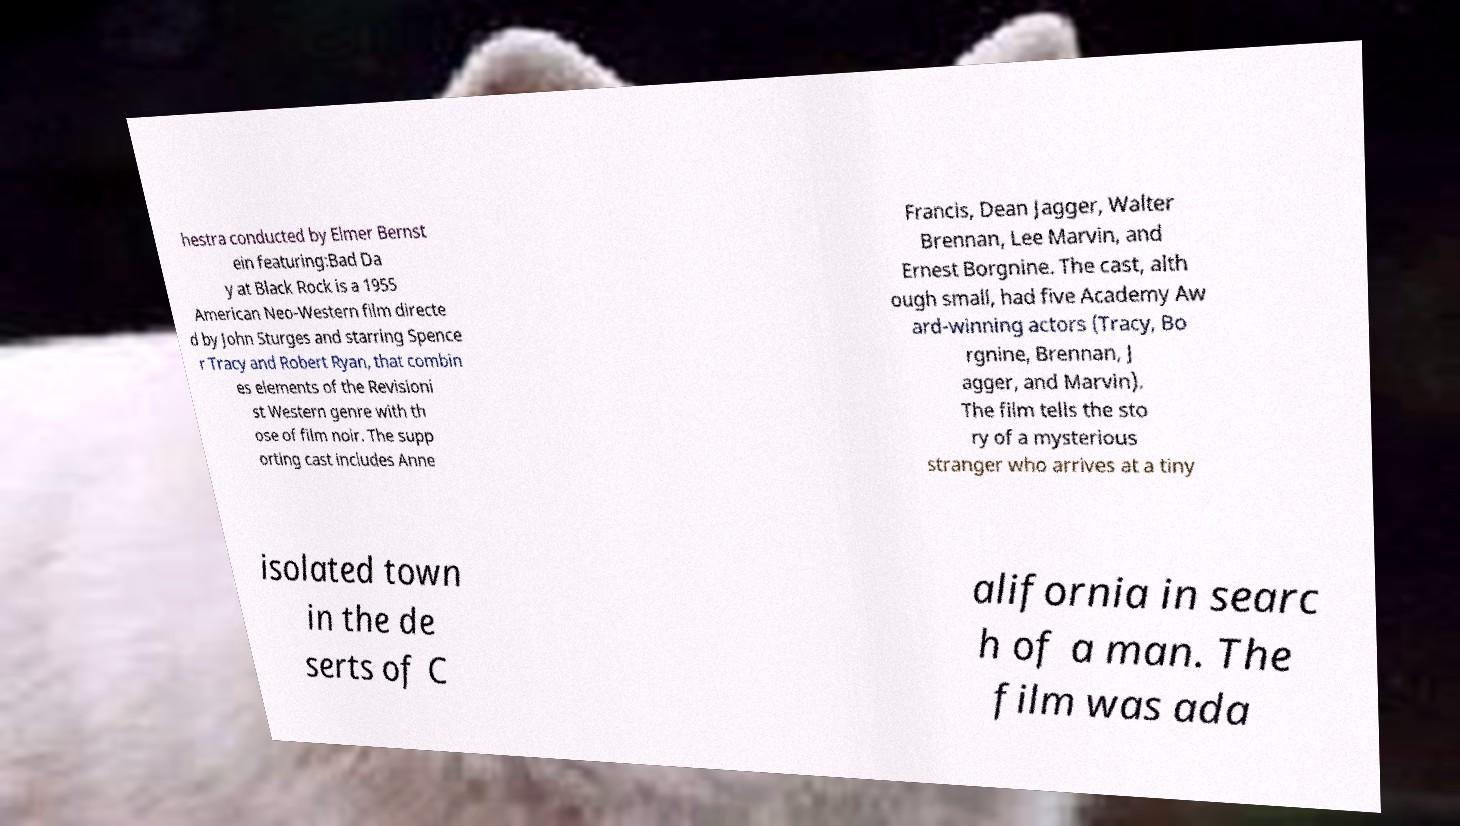Please identify and transcribe the text found in this image. hestra conducted by Elmer Bernst ein featuring:Bad Da y at Black Rock is a 1955 American Neo-Western film directe d by John Sturges and starring Spence r Tracy and Robert Ryan, that combin es elements of the Revisioni st Western genre with th ose of film noir. The supp orting cast includes Anne Francis, Dean Jagger, Walter Brennan, Lee Marvin, and Ernest Borgnine. The cast, alth ough small, had five Academy Aw ard-winning actors (Tracy, Bo rgnine, Brennan, J agger, and Marvin). The film tells the sto ry of a mysterious stranger who arrives at a tiny isolated town in the de serts of C alifornia in searc h of a man. The film was ada 